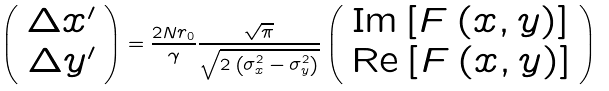Convert formula to latex. <formula><loc_0><loc_0><loc_500><loc_500>\left ( \begin{array} { c } \Delta x ^ { \prime } \\ \Delta y ^ { \prime } \end{array} \right ) = \frac { 2 N r _ { 0 } } { \gamma } \frac { \sqrt { \pi } } { \sqrt { 2 \left ( \sigma _ { x } ^ { 2 } - \sigma _ { y } ^ { 2 } \right ) } } \left ( \begin{array} { c } \text {Im} \left [ F \left ( x , y \right ) \right ] \\ \text {Re} \left [ F \left ( x , y \right ) \right ] \end{array} \right )</formula> 